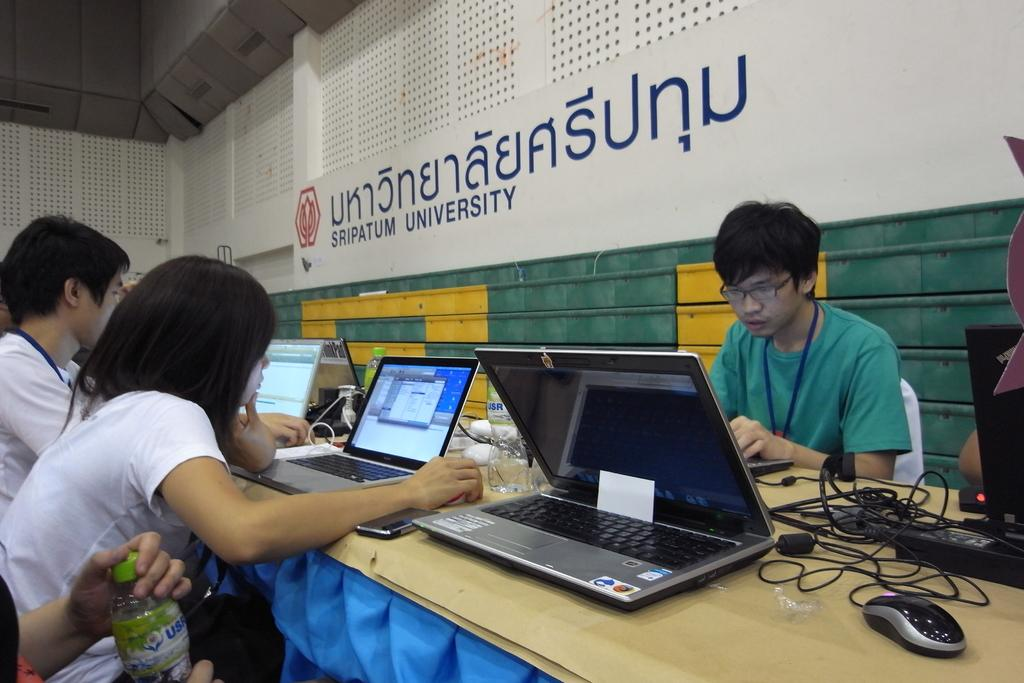<image>
Provide a brief description of the given image. students studying at the sripatum university with their laptops 